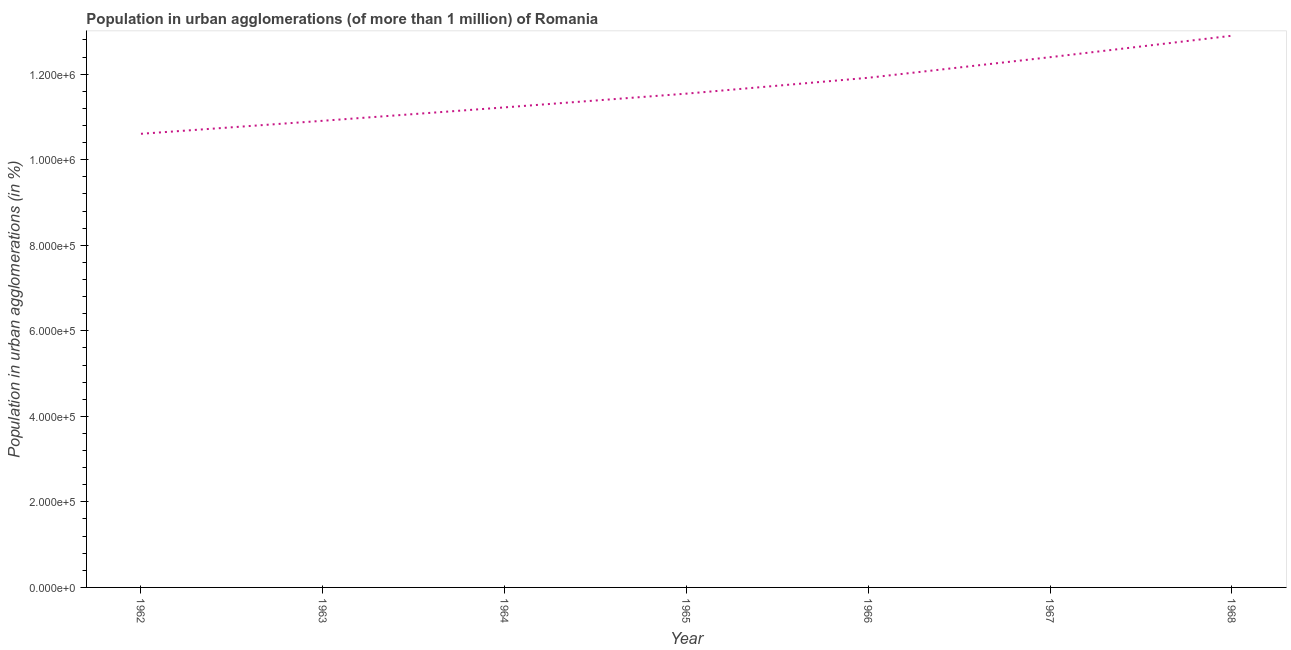What is the population in urban agglomerations in 1968?
Offer a terse response. 1.29e+06. Across all years, what is the maximum population in urban agglomerations?
Ensure brevity in your answer.  1.29e+06. Across all years, what is the minimum population in urban agglomerations?
Give a very brief answer. 1.06e+06. In which year was the population in urban agglomerations maximum?
Offer a very short reply. 1968. In which year was the population in urban agglomerations minimum?
Keep it short and to the point. 1962. What is the sum of the population in urban agglomerations?
Ensure brevity in your answer.  8.15e+06. What is the difference between the population in urban agglomerations in 1962 and 1967?
Your response must be concise. -1.79e+05. What is the average population in urban agglomerations per year?
Give a very brief answer. 1.16e+06. What is the median population in urban agglomerations?
Ensure brevity in your answer.  1.15e+06. In how many years, is the population in urban agglomerations greater than 400000 %?
Make the answer very short. 7. What is the ratio of the population in urban agglomerations in 1962 to that in 1968?
Make the answer very short. 0.82. Is the difference between the population in urban agglomerations in 1963 and 1968 greater than the difference between any two years?
Make the answer very short. No. What is the difference between the highest and the second highest population in urban agglomerations?
Provide a short and direct response. 5.02e+04. What is the difference between the highest and the lowest population in urban agglomerations?
Provide a short and direct response. 2.29e+05. Does the population in urban agglomerations monotonically increase over the years?
Make the answer very short. Yes. What is the difference between two consecutive major ticks on the Y-axis?
Give a very brief answer. 2.00e+05. What is the title of the graph?
Your answer should be very brief. Population in urban agglomerations (of more than 1 million) of Romania. What is the label or title of the Y-axis?
Make the answer very short. Population in urban agglomerations (in %). What is the Population in urban agglomerations (in %) of 1962?
Give a very brief answer. 1.06e+06. What is the Population in urban agglomerations (in %) in 1963?
Your answer should be compact. 1.09e+06. What is the Population in urban agglomerations (in %) in 1964?
Offer a terse response. 1.12e+06. What is the Population in urban agglomerations (in %) in 1965?
Offer a terse response. 1.15e+06. What is the Population in urban agglomerations (in %) in 1966?
Keep it short and to the point. 1.19e+06. What is the Population in urban agglomerations (in %) of 1967?
Your answer should be very brief. 1.24e+06. What is the Population in urban agglomerations (in %) in 1968?
Make the answer very short. 1.29e+06. What is the difference between the Population in urban agglomerations (in %) in 1962 and 1963?
Your response must be concise. -3.04e+04. What is the difference between the Population in urban agglomerations (in %) in 1962 and 1964?
Keep it short and to the point. -6.17e+04. What is the difference between the Population in urban agglomerations (in %) in 1962 and 1965?
Offer a very short reply. -9.39e+04. What is the difference between the Population in urban agglomerations (in %) in 1962 and 1966?
Your response must be concise. -1.31e+05. What is the difference between the Population in urban agglomerations (in %) in 1962 and 1967?
Provide a succinct answer. -1.79e+05. What is the difference between the Population in urban agglomerations (in %) in 1962 and 1968?
Offer a terse response. -2.29e+05. What is the difference between the Population in urban agglomerations (in %) in 1963 and 1964?
Make the answer very short. -3.13e+04. What is the difference between the Population in urban agglomerations (in %) in 1963 and 1965?
Provide a short and direct response. -6.35e+04. What is the difference between the Population in urban agglomerations (in %) in 1963 and 1966?
Keep it short and to the point. -1.01e+05. What is the difference between the Population in urban agglomerations (in %) in 1963 and 1967?
Your answer should be compact. -1.49e+05. What is the difference between the Population in urban agglomerations (in %) in 1963 and 1968?
Give a very brief answer. -1.99e+05. What is the difference between the Population in urban agglomerations (in %) in 1964 and 1965?
Give a very brief answer. -3.21e+04. What is the difference between the Population in urban agglomerations (in %) in 1964 and 1966?
Offer a terse response. -6.92e+04. What is the difference between the Population in urban agglomerations (in %) in 1964 and 1967?
Your answer should be compact. -1.17e+05. What is the difference between the Population in urban agglomerations (in %) in 1964 and 1968?
Ensure brevity in your answer.  -1.68e+05. What is the difference between the Population in urban agglomerations (in %) in 1965 and 1966?
Keep it short and to the point. -3.71e+04. What is the difference between the Population in urban agglomerations (in %) in 1965 and 1967?
Your answer should be compact. -8.52e+04. What is the difference between the Population in urban agglomerations (in %) in 1965 and 1968?
Keep it short and to the point. -1.35e+05. What is the difference between the Population in urban agglomerations (in %) in 1966 and 1967?
Provide a short and direct response. -4.81e+04. What is the difference between the Population in urban agglomerations (in %) in 1966 and 1968?
Offer a very short reply. -9.83e+04. What is the difference between the Population in urban agglomerations (in %) in 1967 and 1968?
Provide a succinct answer. -5.02e+04. What is the ratio of the Population in urban agglomerations (in %) in 1962 to that in 1963?
Your answer should be very brief. 0.97. What is the ratio of the Population in urban agglomerations (in %) in 1962 to that in 1964?
Your response must be concise. 0.94. What is the ratio of the Population in urban agglomerations (in %) in 1962 to that in 1965?
Your answer should be very brief. 0.92. What is the ratio of the Population in urban agglomerations (in %) in 1962 to that in 1966?
Offer a terse response. 0.89. What is the ratio of the Population in urban agglomerations (in %) in 1962 to that in 1967?
Ensure brevity in your answer.  0.86. What is the ratio of the Population in urban agglomerations (in %) in 1962 to that in 1968?
Provide a short and direct response. 0.82. What is the ratio of the Population in urban agglomerations (in %) in 1963 to that in 1965?
Provide a short and direct response. 0.94. What is the ratio of the Population in urban agglomerations (in %) in 1963 to that in 1966?
Offer a terse response. 0.92. What is the ratio of the Population in urban agglomerations (in %) in 1963 to that in 1967?
Provide a short and direct response. 0.88. What is the ratio of the Population in urban agglomerations (in %) in 1963 to that in 1968?
Make the answer very short. 0.85. What is the ratio of the Population in urban agglomerations (in %) in 1964 to that in 1966?
Offer a very short reply. 0.94. What is the ratio of the Population in urban agglomerations (in %) in 1964 to that in 1967?
Ensure brevity in your answer.  0.91. What is the ratio of the Population in urban agglomerations (in %) in 1964 to that in 1968?
Give a very brief answer. 0.87. What is the ratio of the Population in urban agglomerations (in %) in 1965 to that in 1968?
Make the answer very short. 0.9. What is the ratio of the Population in urban agglomerations (in %) in 1966 to that in 1967?
Your response must be concise. 0.96. What is the ratio of the Population in urban agglomerations (in %) in 1966 to that in 1968?
Offer a terse response. 0.92. 